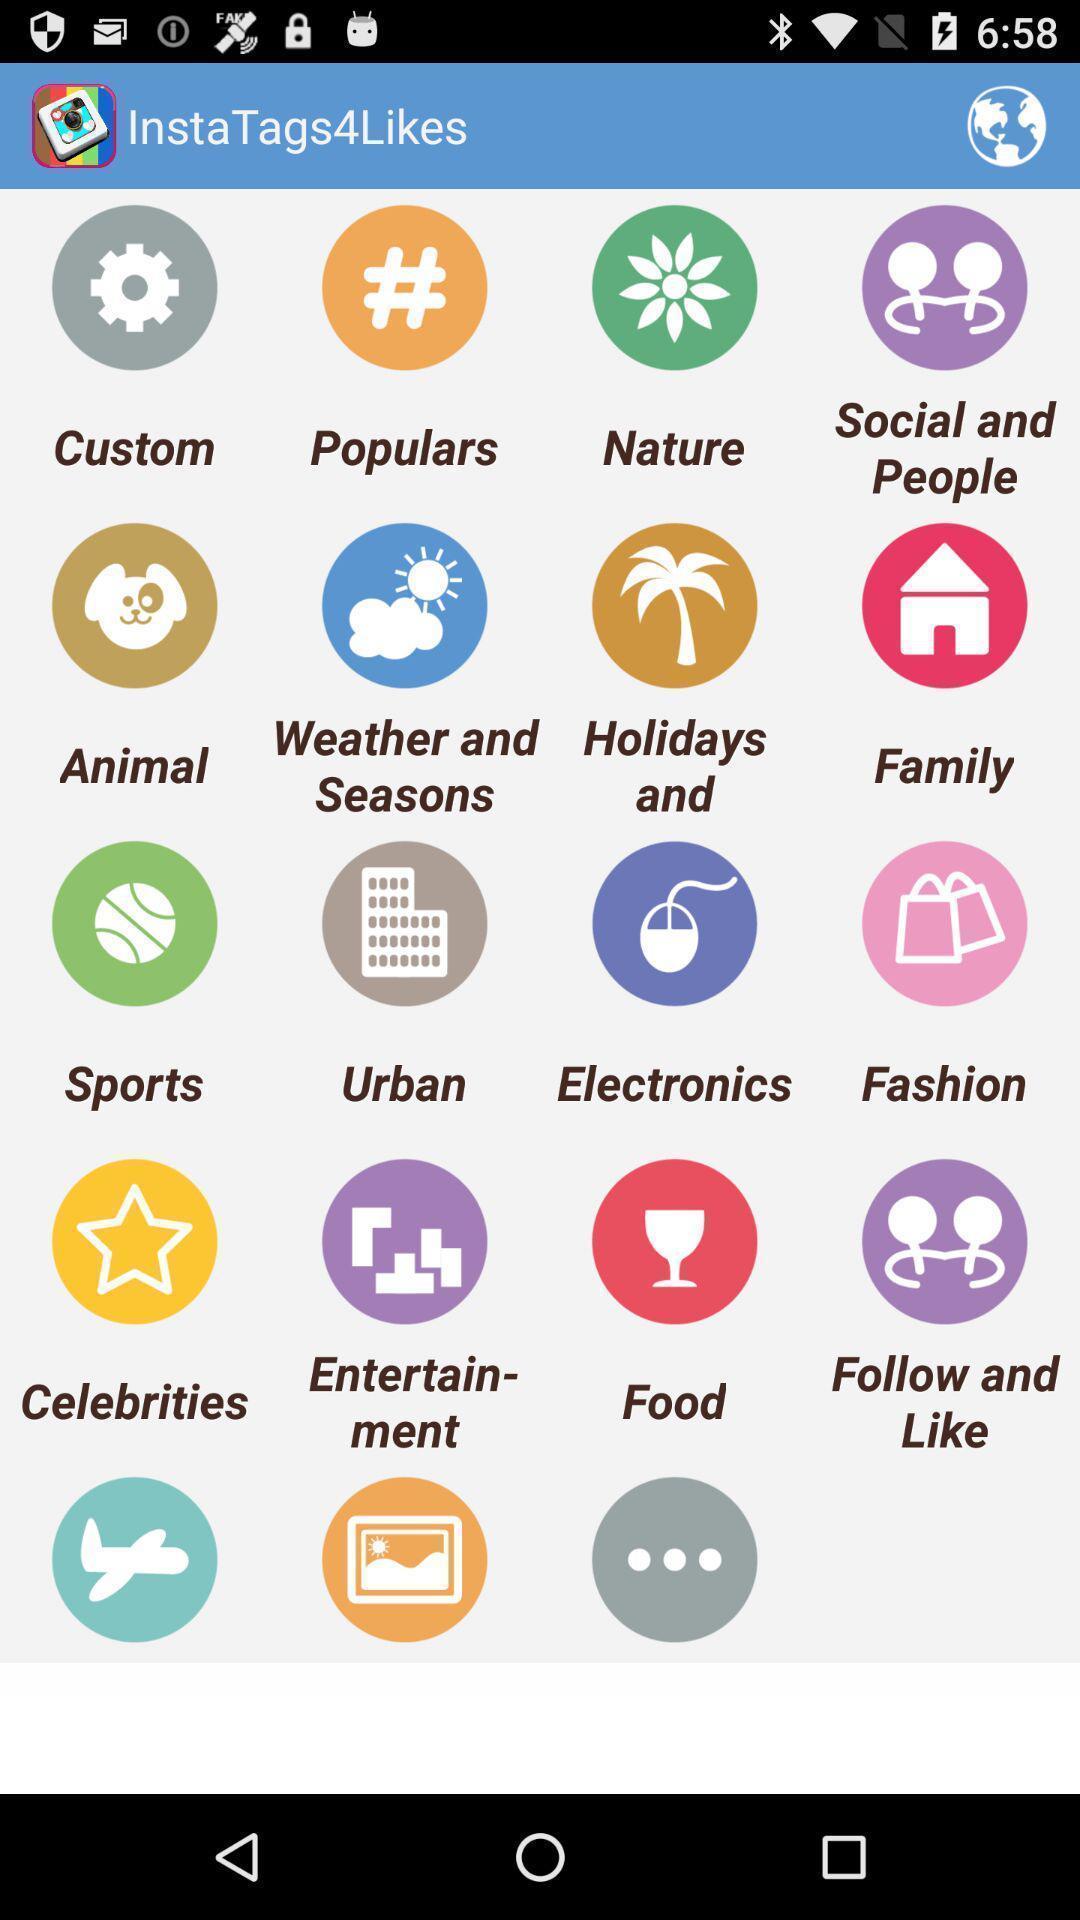Give me a summary of this screen capture. Page showing different applications. 